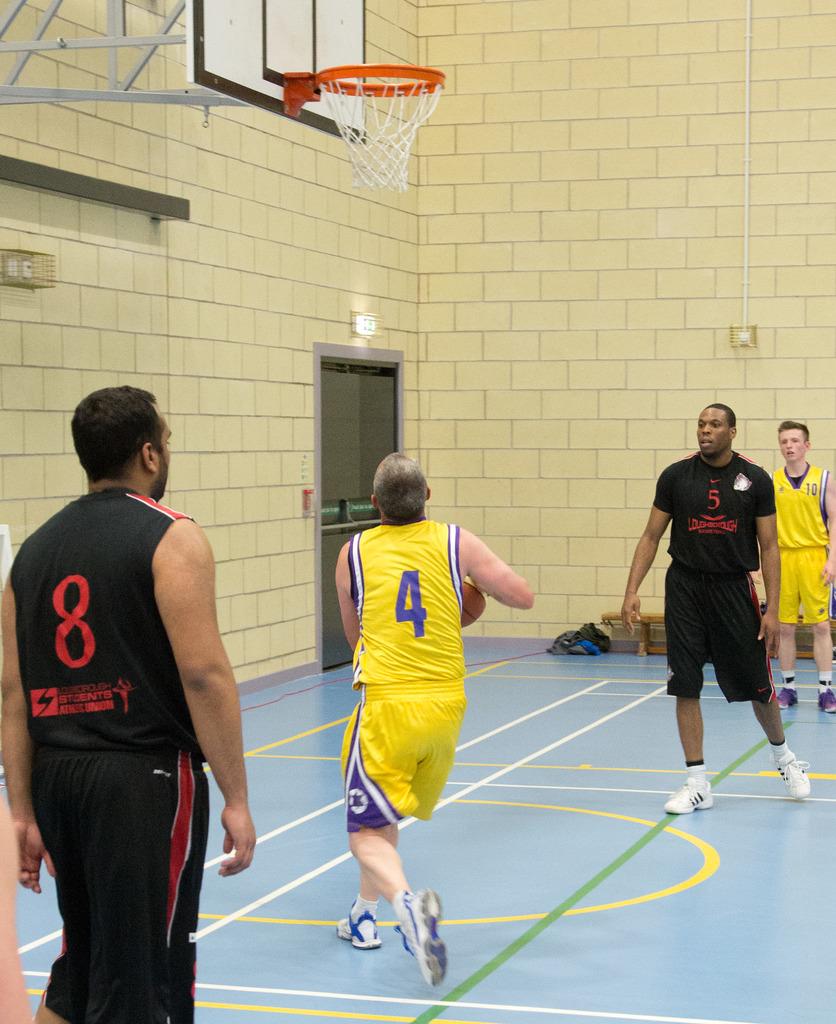What number is the player on the left wearing?
Your answer should be compact. 8. What player number is preparing to attempt a layup?
Your answer should be very brief. 4. 